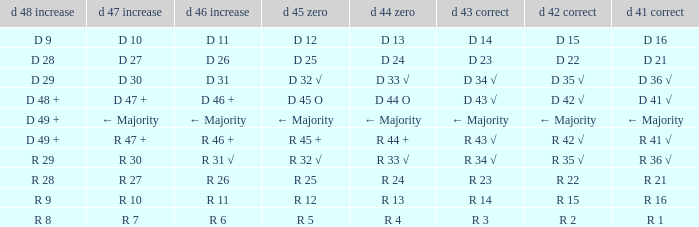What is the value of D 46 +, when the value of D 42 √ is r 2? R 6. 